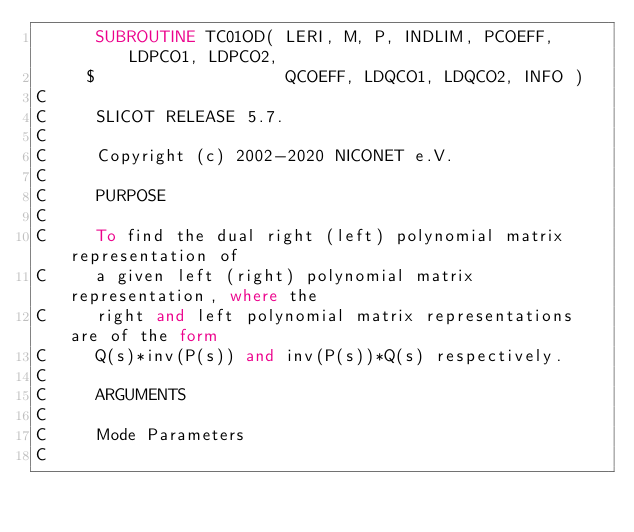Convert code to text. <code><loc_0><loc_0><loc_500><loc_500><_FORTRAN_>      SUBROUTINE TC01OD( LERI, M, P, INDLIM, PCOEFF, LDPCO1, LDPCO2,
     $                   QCOEFF, LDQCO1, LDQCO2, INFO )
C
C     SLICOT RELEASE 5.7.
C
C     Copyright (c) 2002-2020 NICONET e.V.
C
C     PURPOSE
C
C     To find the dual right (left) polynomial matrix representation of
C     a given left (right) polynomial matrix representation, where the
C     right and left polynomial matrix representations are of the form
C     Q(s)*inv(P(s)) and inv(P(s))*Q(s) respectively.
C
C     ARGUMENTS
C
C     Mode Parameters
C</code> 